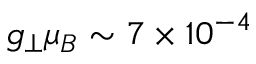Convert formula to latex. <formula><loc_0><loc_0><loc_500><loc_500>g _ { \perp } \mu _ { B } \sim 7 \times 1 0 ^ { - 4 }</formula> 